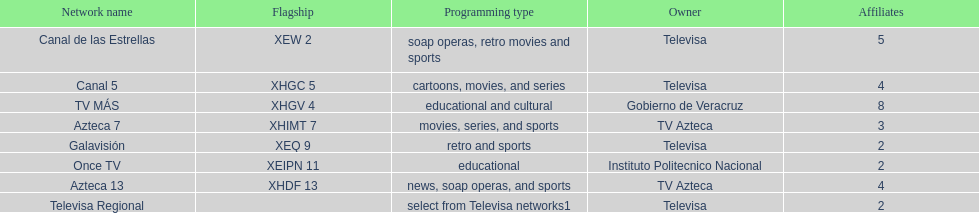How many networks show soap operas? 2. 